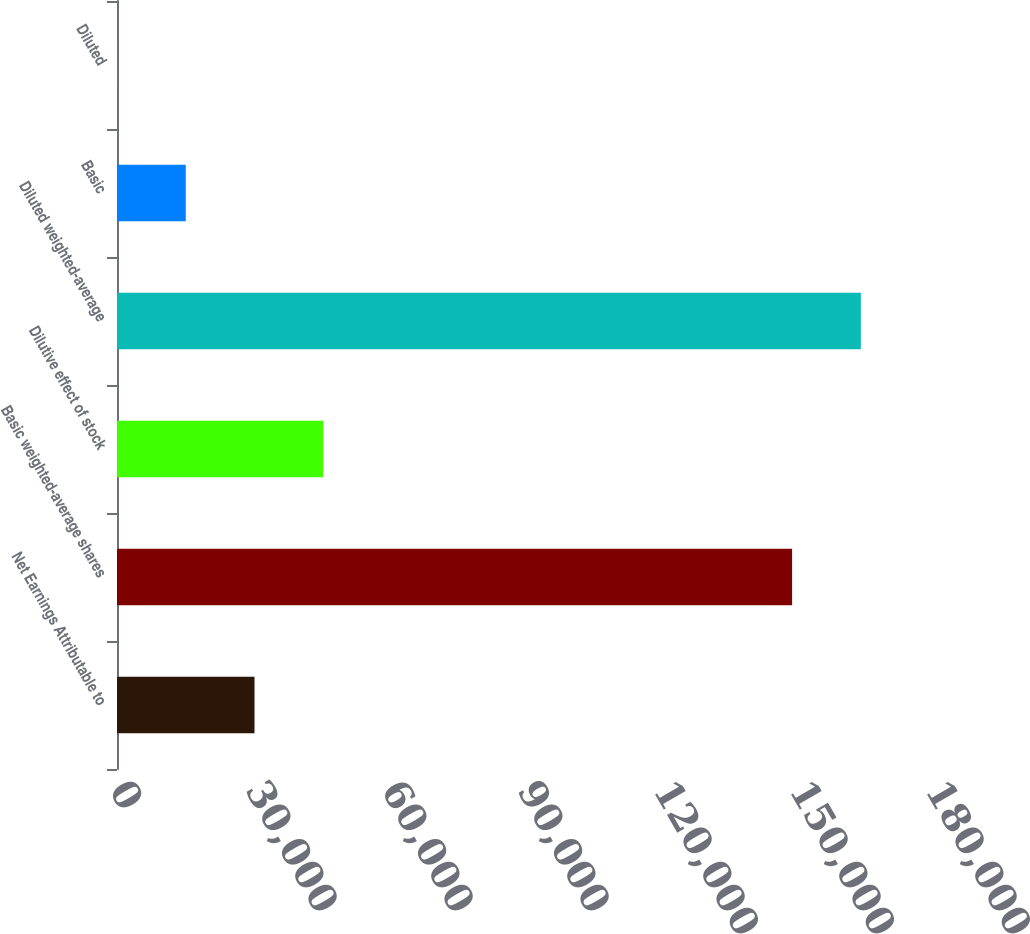Convert chart to OTSL. <chart><loc_0><loc_0><loc_500><loc_500><bar_chart><fcel>Net Earnings Attributable to<fcel>Basic weighted-average shares<fcel>Dilutive effect of stock<fcel>Diluted weighted-average<fcel>Basic<fcel>Diluted<nl><fcel>30331.8<fcel>148919<fcel>45495.7<fcel>164083<fcel>15167.9<fcel>3.99<nl></chart> 